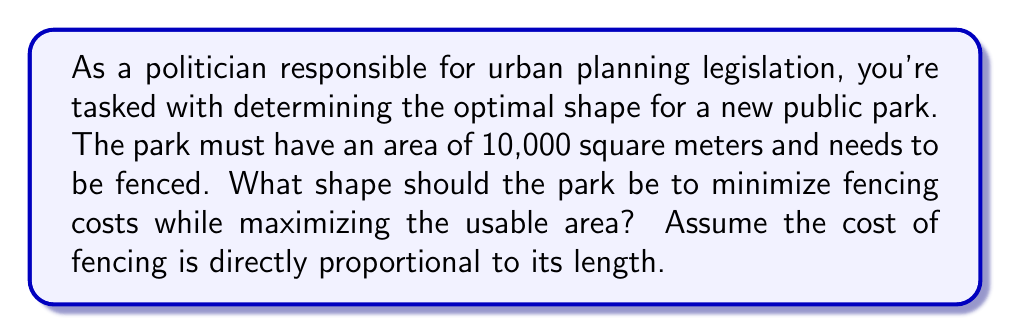Can you solve this math problem? Let's approach this step-by-step:

1) The shape that encloses the maximum area with the minimum perimeter is a circle. This is known as the isoperimetric theorem.

2) For a circle:
   Area = $\pi r^2$
   Circumference = $2\pi r$

3) Given the area of 10,000 square meters:
   $10000 = \pi r^2$

4) Solving for $r$:
   $r^2 = \frac{10000}{\pi}$
   $r = \sqrt{\frac{10000}{\pi}} \approx 56.42$ meters

5) The circumference (fencing needed) would be:
   $2\pi r = 2\pi \sqrt{\frac{10000}{\pi}} \approx 354.49$ meters

6) To compare, let's calculate for a square shape:
   Side length = $\sqrt{10000} = 100$ meters
   Perimeter = $4 * 100 = 400$ meters

7) The circular shape requires approximately 45.51 meters less fencing than a square shape.

[asy]
unitsize(1cm);
draw(circle((0,0),2.5), rgb(0,0,1));
draw((-2.5,-2.5)--(2.5,-2.5)--(2.5,2.5)--(-2.5,2.5)--cycle, rgb(1,0,0));
label("Circle", (0,-3), rgb(0,0,1));
label("Square", (3,0), rgb(1,0,0));
[/asy]

Therefore, a circular shape is optimal for minimizing fencing costs while maximizing the usable area of the park.
Answer: Circular shape 